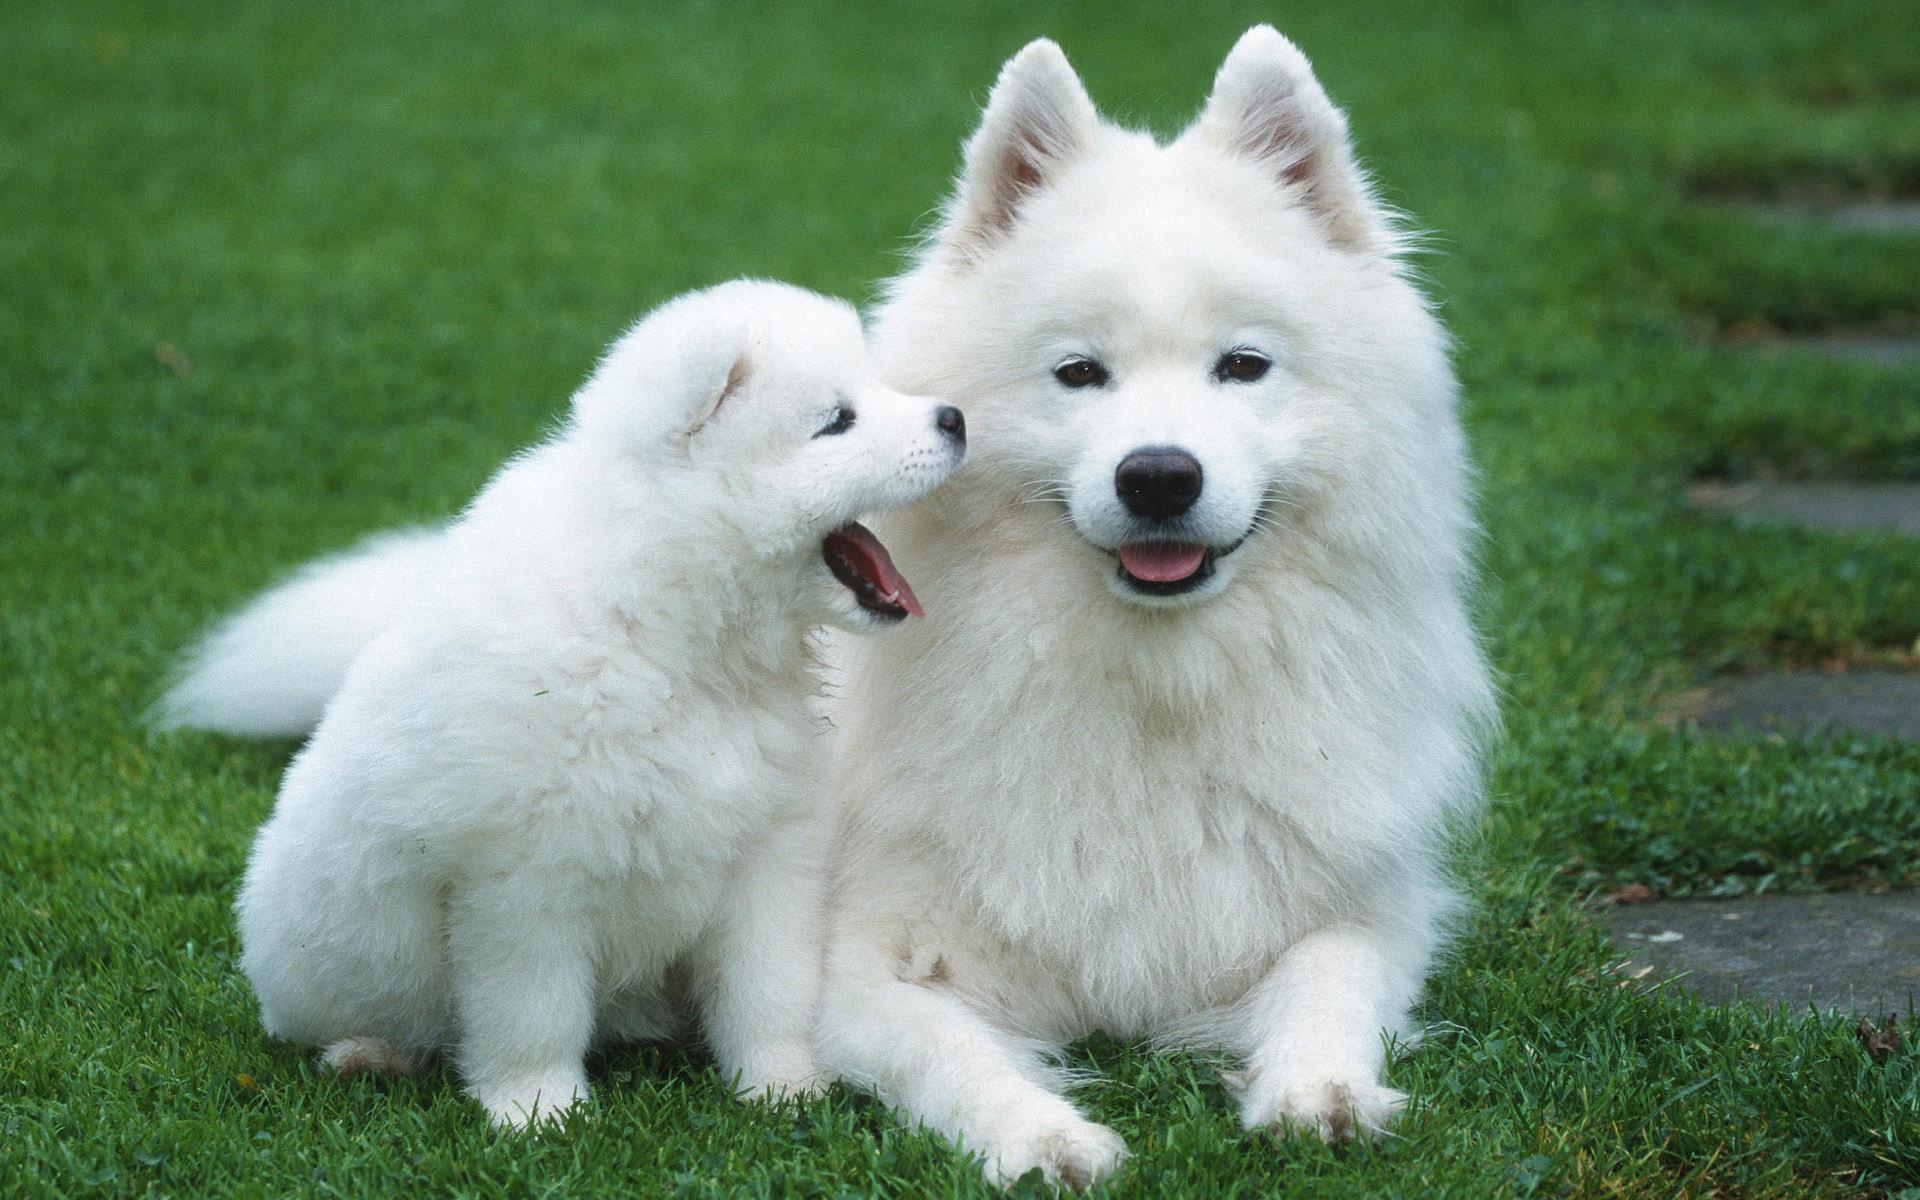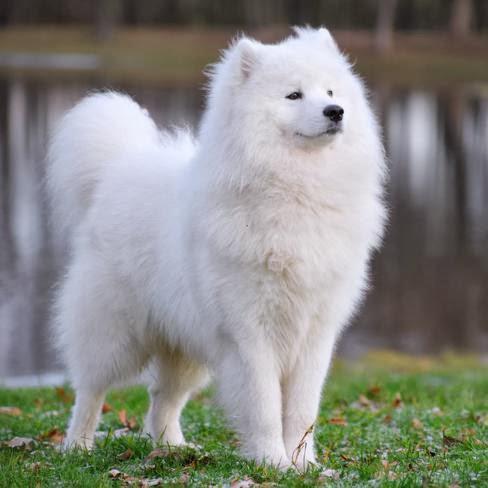The first image is the image on the left, the second image is the image on the right. Considering the images on both sides, is "Each image contains exactly one dog, and all dogs are white and posed outdoors." valid? Answer yes or no. No. The first image is the image on the left, the second image is the image on the right. Assess this claim about the two images: "The dog in the image on the right is standing on the grass.". Correct or not? Answer yes or no. Yes. 